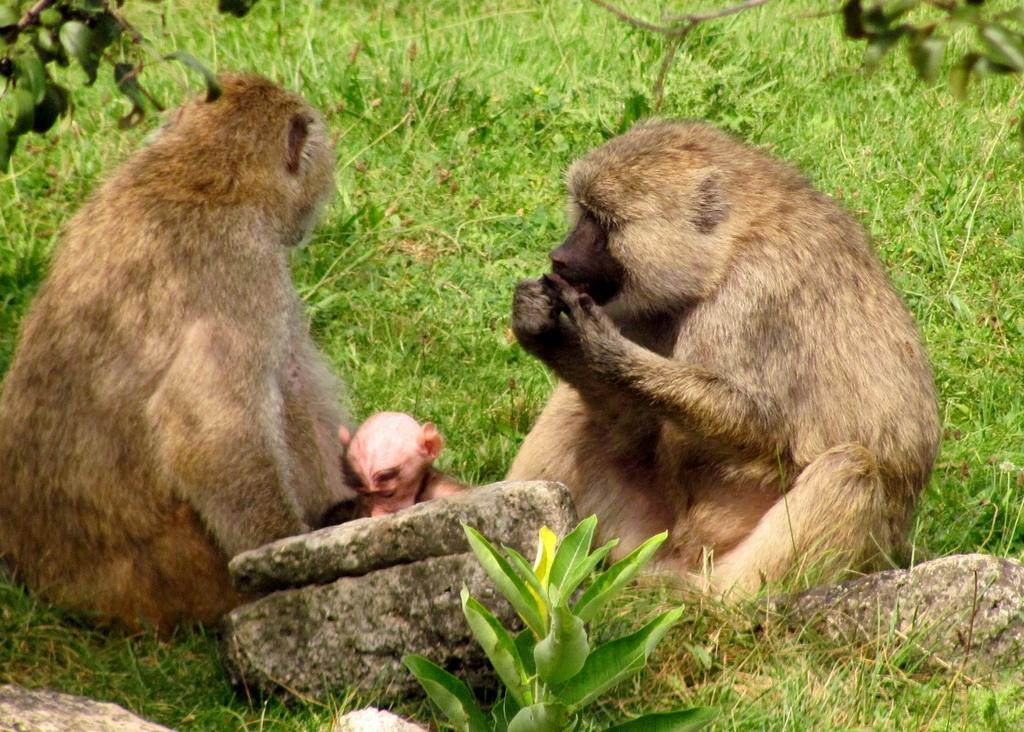Where was the picture taken? The picture was taken outside. What can be seen in the center of the image? There are two monkeys sitting on the ground in the center of the image. What type of vegetation is visible in the image? There is green grass and plants in the image. What type of natural features can be seen in the image? There are rocks in the image. What else is present in the image besides the monkeys and natural features? There are other objects present in the image. Reasoning: Let's think step by step by breaking down the facts into specific details about the image. We start by identifying the location of the image, which is outside. Then, we focus on the main subjects, which are the two monkeys sitting on the ground. Next, we describe the natural features and vegetation present in the image, such as the green grass, plants, and rocks. Finally, we acknowledge the presence of other objects in the image that are not specifically mentioned in the facts. Absurd Question/Answer: What type of slope can be seen in the image? There is no slope present in the image; it is taken outside with monkeys sitting on the ground and other natural features. What kind of test is being conducted in the image? There is no test being conducted in the image; it features monkeys and natural elements. 